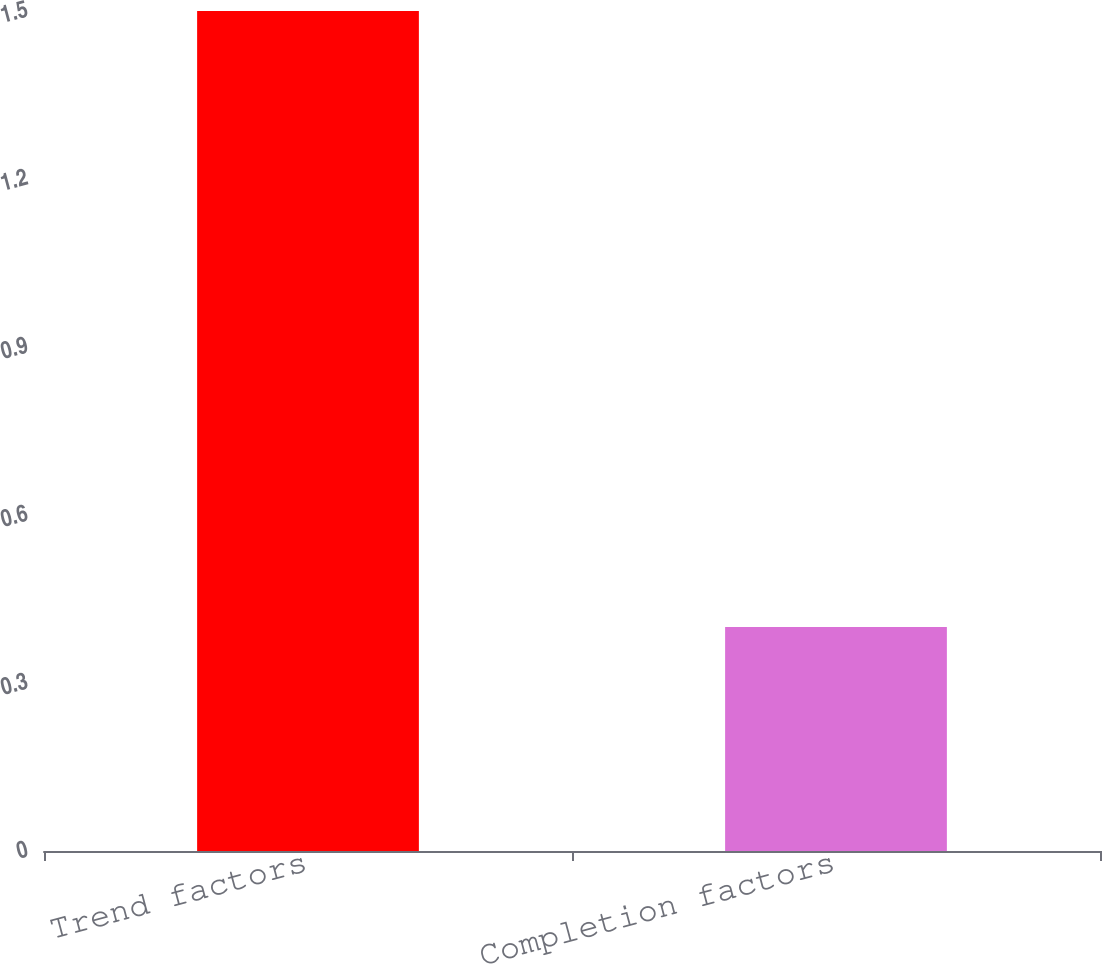<chart> <loc_0><loc_0><loc_500><loc_500><bar_chart><fcel>Trend factors<fcel>Completion factors<nl><fcel>1.5<fcel>0.4<nl></chart> 